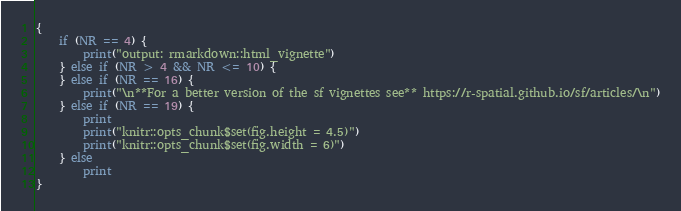Convert code to text. <code><loc_0><loc_0><loc_500><loc_500><_Awk_>{
	if (NR == 4) {
		print("output: rmarkdown::html_vignette")
	} else if (NR > 4 && NR <= 10) {
	} else if (NR == 16) {
		print("\n**For a better version of the sf vignettes see** https://r-spatial.github.io/sf/articles/\n")
	} else if (NR == 19) {
		print
		print("knitr::opts_chunk$set(fig.height = 4.5)")
		print("knitr::opts_chunk$set(fig.width = 6)")
	} else
		print
}
</code> 